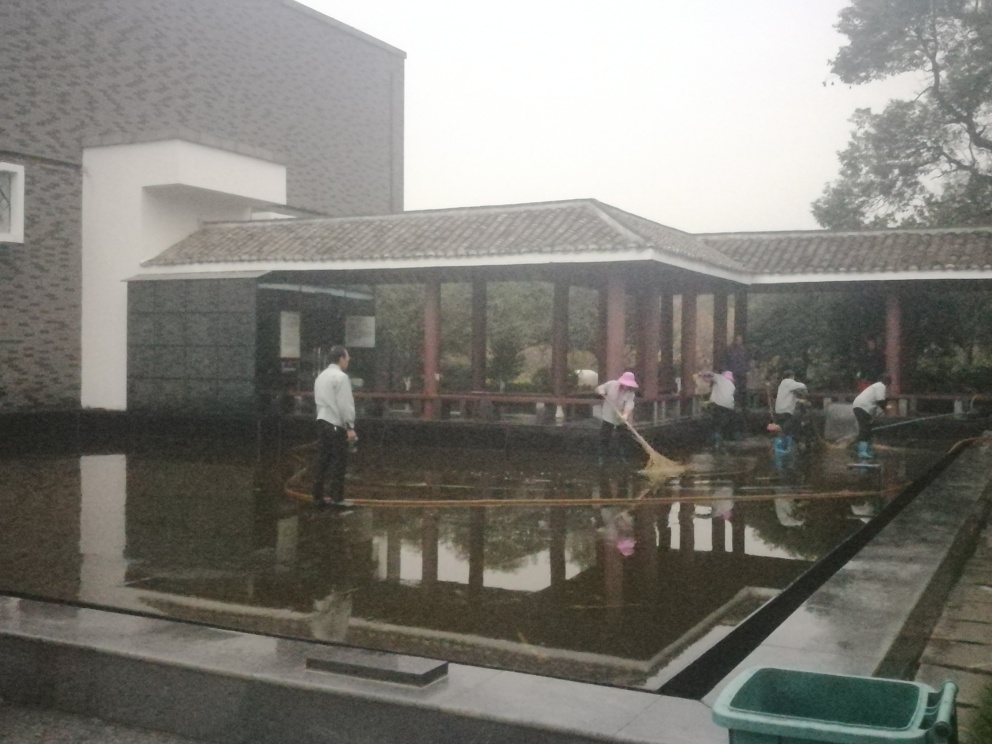What activity is taking place in this image? The image shows a group of people engaged in cleaning what appears to be an outdoor pond or water feature. They are using long-handled tools to reach into the water, likely to remove debris or maintain the cleanliness of the area. Does this seem to be a part of a routine maintenance or a special event? Given the number of people involved and the systematic approach to their task, it suggests that this is a routine maintenance activity. Special events typically involve more varied activities and may not focus as much on cleaning efforts. 